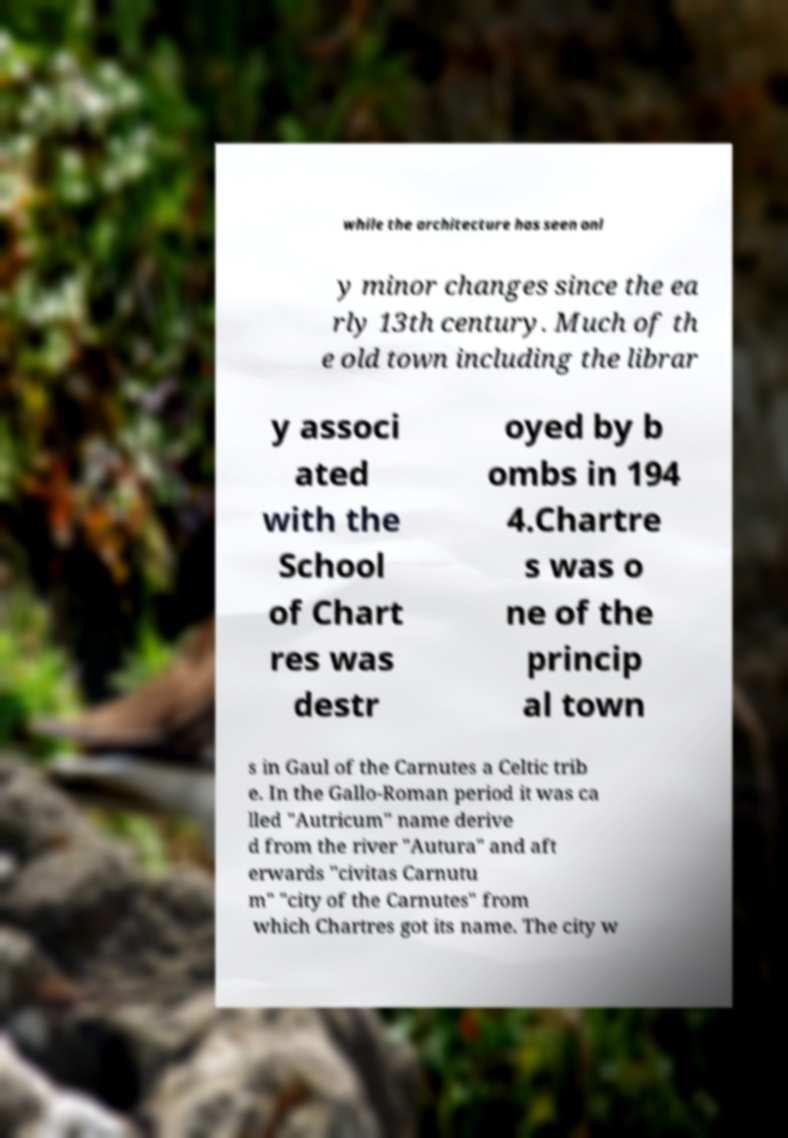Could you extract and type out the text from this image? while the architecture has seen onl y minor changes since the ea rly 13th century. Much of th e old town including the librar y associ ated with the School of Chart res was destr oyed by b ombs in 194 4.Chartre s was o ne of the princip al town s in Gaul of the Carnutes a Celtic trib e. In the Gallo-Roman period it was ca lled "Autricum" name derive d from the river "Autura" and aft erwards "civitas Carnutu m" "city of the Carnutes" from which Chartres got its name. The city w 